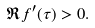Convert formula to latex. <formula><loc_0><loc_0><loc_500><loc_500>\Re f ^ { \prime } ( \tau ) > 0 .</formula> 